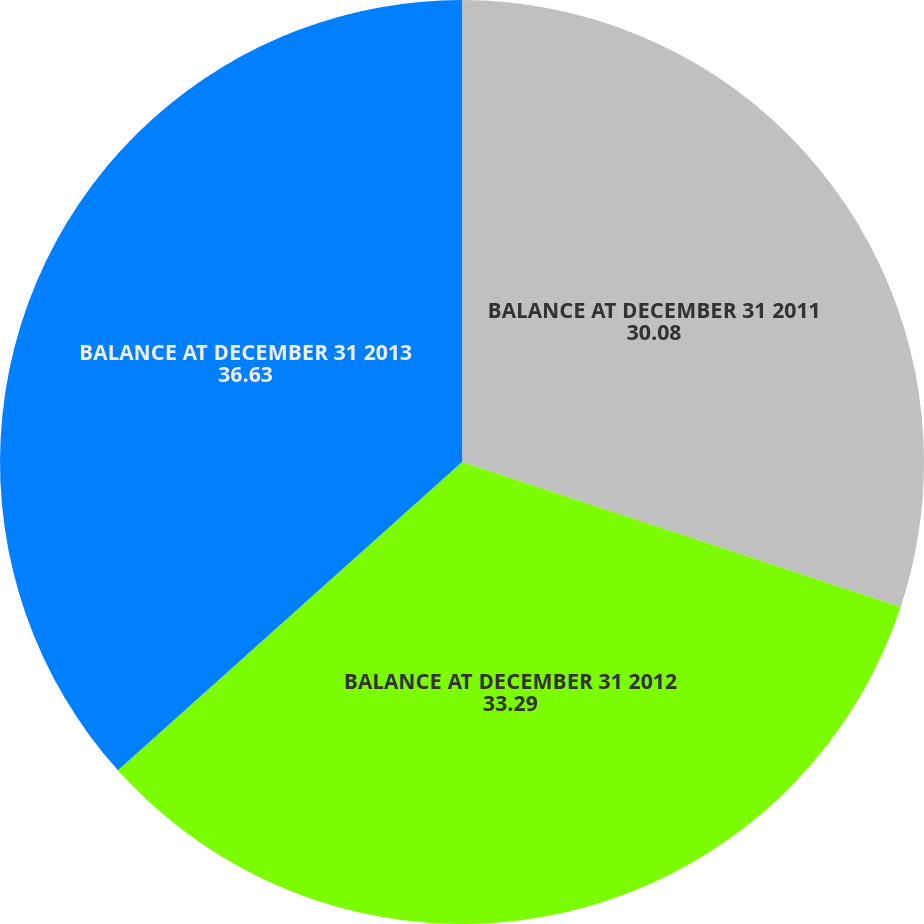<chart> <loc_0><loc_0><loc_500><loc_500><pie_chart><fcel>BALANCE AT DECEMBER 31 2011<fcel>BALANCE AT DECEMBER 31 2012<fcel>BALANCE AT DECEMBER 31 2013<nl><fcel>30.08%<fcel>33.29%<fcel>36.63%<nl></chart> 